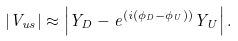Convert formula to latex. <formula><loc_0><loc_0><loc_500><loc_500>\left | { V _ { u s } } \right | \approx \left | { Y _ { D } } - e ^ { ( i ( { \phi _ { D } } - { \phi _ { U } } ) ) } { Y _ { U } } \right | .</formula> 